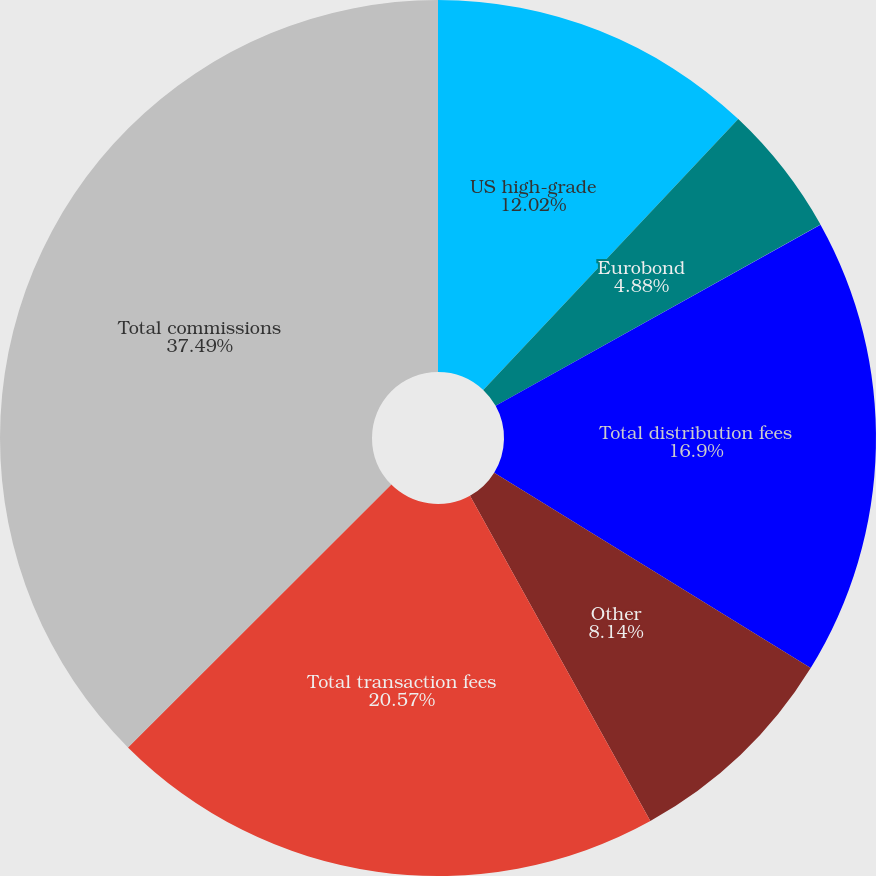Convert chart to OTSL. <chart><loc_0><loc_0><loc_500><loc_500><pie_chart><fcel>US high-grade<fcel>Eurobond<fcel>Total distribution fees<fcel>Other<fcel>Total transaction fees<fcel>Total commissions<nl><fcel>12.02%<fcel>4.88%<fcel>16.9%<fcel>8.14%<fcel>20.57%<fcel>37.48%<nl></chart> 